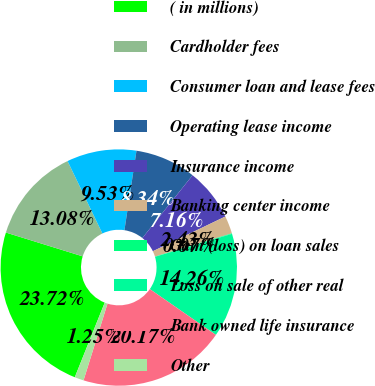<chart> <loc_0><loc_0><loc_500><loc_500><pie_chart><fcel>( in millions)<fcel>Cardholder fees<fcel>Consumer loan and lease fees<fcel>Operating lease income<fcel>Insurance income<fcel>Banking center income<fcel>Gain (loss) on loan sales<fcel>Loss on sale of other real<fcel>Bank owned life insurance<fcel>Other<nl><fcel>23.72%<fcel>13.08%<fcel>9.53%<fcel>8.34%<fcel>7.16%<fcel>2.43%<fcel>0.07%<fcel>14.26%<fcel>20.17%<fcel>1.25%<nl></chart> 